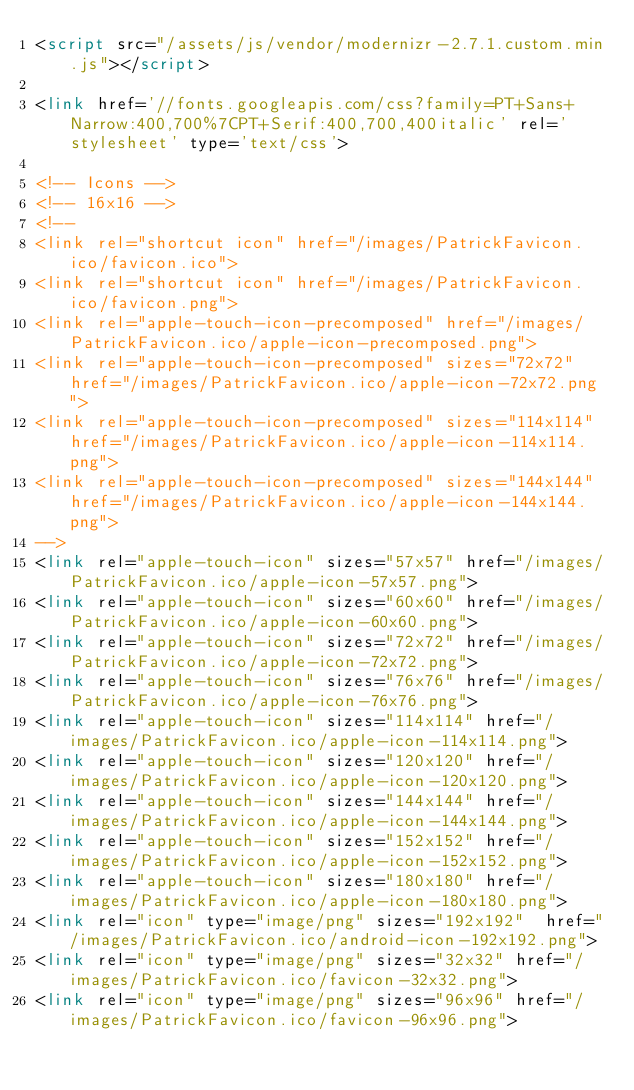<code> <loc_0><loc_0><loc_500><loc_500><_HTML_><script src="/assets/js/vendor/modernizr-2.7.1.custom.min.js"></script>

<link href='//fonts.googleapis.com/css?family=PT+Sans+Narrow:400,700%7CPT+Serif:400,700,400italic' rel='stylesheet' type='text/css'>

<!-- Icons -->
<!-- 16x16 -->
<!--
<link rel="shortcut icon" href="/images/PatrickFavicon.ico/favicon.ico">
<link rel="shortcut icon" href="/images/PatrickFavicon.ico/favicon.png">
<link rel="apple-touch-icon-precomposed" href="/images/PatrickFavicon.ico/apple-icon-precomposed.png">
<link rel="apple-touch-icon-precomposed" sizes="72x72" href="/images/PatrickFavicon.ico/apple-icon-72x72.png">
<link rel="apple-touch-icon-precomposed" sizes="114x114" href="/images/PatrickFavicon.ico/apple-icon-114x114.png">
<link rel="apple-touch-icon-precomposed" sizes="144x144" href="/images/PatrickFavicon.ico/apple-icon-144x144.png">
-->
<link rel="apple-touch-icon" sizes="57x57" href="/images/PatrickFavicon.ico/apple-icon-57x57.png">
<link rel="apple-touch-icon" sizes="60x60" href="/images/PatrickFavicon.ico/apple-icon-60x60.png">
<link rel="apple-touch-icon" sizes="72x72" href="/images/PatrickFavicon.ico/apple-icon-72x72.png">
<link rel="apple-touch-icon" sizes="76x76" href="/images/PatrickFavicon.ico/apple-icon-76x76.png">
<link rel="apple-touch-icon" sizes="114x114" href="/images/PatrickFavicon.ico/apple-icon-114x114.png">
<link rel="apple-touch-icon" sizes="120x120" href="/images/PatrickFavicon.ico/apple-icon-120x120.png">
<link rel="apple-touch-icon" sizes="144x144" href="/images/PatrickFavicon.ico/apple-icon-144x144.png">
<link rel="apple-touch-icon" sizes="152x152" href="/images/PatrickFavicon.ico/apple-icon-152x152.png">
<link rel="apple-touch-icon" sizes="180x180" href="/images/PatrickFavicon.ico/apple-icon-180x180.png">
<link rel="icon" type="image/png" sizes="192x192"  href="/images/PatrickFavicon.ico/android-icon-192x192.png">
<link rel="icon" type="image/png" sizes="32x32" href="/images/PatrickFavicon.ico/favicon-32x32.png">
<link rel="icon" type="image/png" sizes="96x96" href="/images/PatrickFavicon.ico/favicon-96x96.png"></code> 